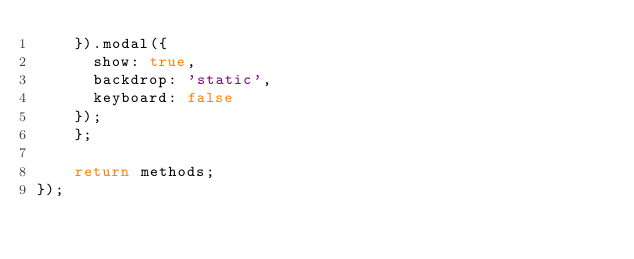<code> <loc_0><loc_0><loc_500><loc_500><_JavaScript_>    }).modal({
      show: true,
      backdrop: 'static',
      keyboard: false
    });
	};

	return methods;
});
</code> 